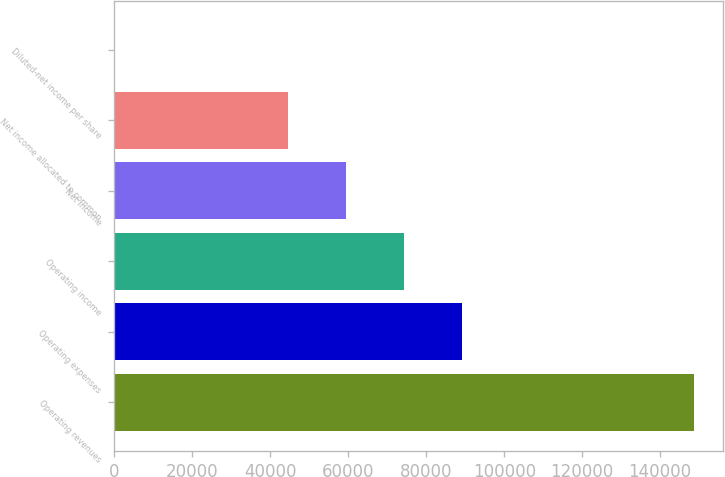<chart> <loc_0><loc_0><loc_500><loc_500><bar_chart><fcel>Operating revenues<fcel>Operating expenses<fcel>Operating income<fcel>Net income<fcel>Net income allocated to common<fcel>Diluted-net income per share<nl><fcel>148725<fcel>89263.4<fcel>74390.9<fcel>59518.4<fcel>44646<fcel>0.54<nl></chart> 